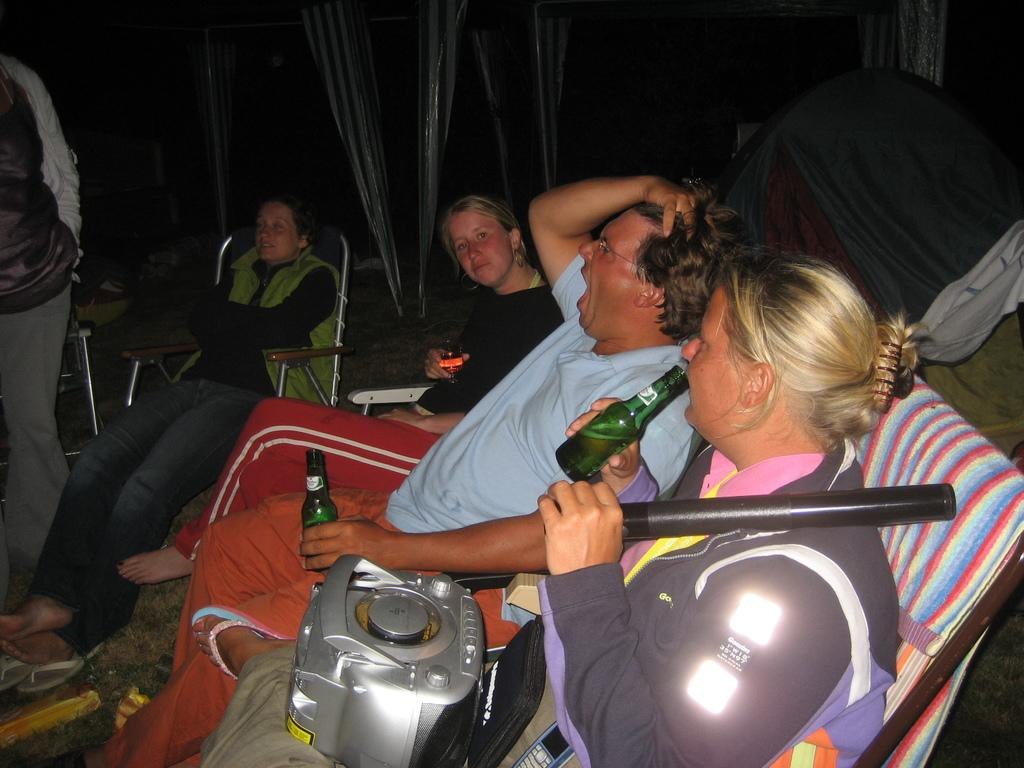What are the people in the image doing? The people in the image are sitting in chairs. What objects are the people holding in their hands? The people are holding bottles in their hands. Can you describe any additional objects in the image? Yes, there is a tape recorder on the lap of a woman in the image. What type of canvas is being used by the bears in the image? There are no bears present in the image, so there is no canvas being used by them. 